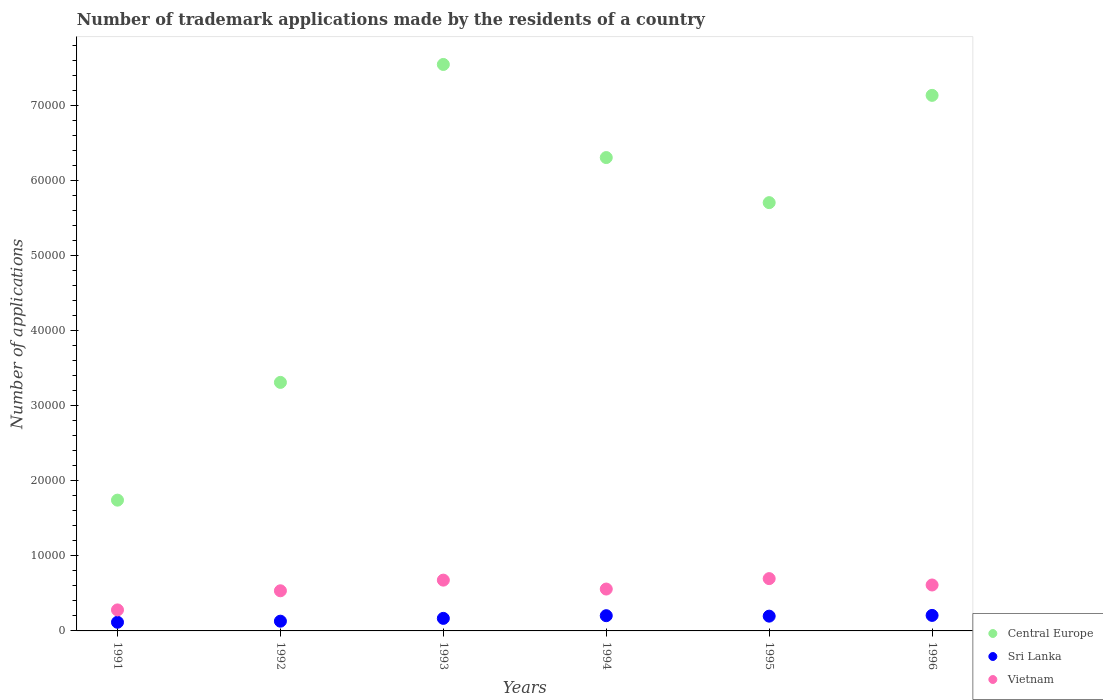Is the number of dotlines equal to the number of legend labels?
Keep it short and to the point. Yes. What is the number of trademark applications made by the residents in Vietnam in 1992?
Your answer should be very brief. 5345. Across all years, what is the maximum number of trademark applications made by the residents in Central Europe?
Your response must be concise. 7.54e+04. Across all years, what is the minimum number of trademark applications made by the residents in Central Europe?
Give a very brief answer. 1.74e+04. In which year was the number of trademark applications made by the residents in Central Europe maximum?
Provide a succinct answer. 1993. In which year was the number of trademark applications made by the residents in Central Europe minimum?
Offer a very short reply. 1991. What is the total number of trademark applications made by the residents in Central Europe in the graph?
Ensure brevity in your answer.  3.17e+05. What is the difference between the number of trademark applications made by the residents in Central Europe in 1991 and that in 1992?
Give a very brief answer. -1.57e+04. What is the difference between the number of trademark applications made by the residents in Sri Lanka in 1994 and the number of trademark applications made by the residents in Vietnam in 1996?
Your response must be concise. -4089. What is the average number of trademark applications made by the residents in Sri Lanka per year?
Your response must be concise. 1697. In the year 1992, what is the difference between the number of trademark applications made by the residents in Central Europe and number of trademark applications made by the residents in Vietnam?
Make the answer very short. 2.78e+04. What is the ratio of the number of trademark applications made by the residents in Central Europe in 1991 to that in 1996?
Make the answer very short. 0.24. Is the number of trademark applications made by the residents in Sri Lanka in 1992 less than that in 1995?
Make the answer very short. Yes. What is the difference between the highest and the second highest number of trademark applications made by the residents in Vietnam?
Ensure brevity in your answer.  202. What is the difference between the highest and the lowest number of trademark applications made by the residents in Vietnam?
Keep it short and to the point. 4168. In how many years, is the number of trademark applications made by the residents in Central Europe greater than the average number of trademark applications made by the residents in Central Europe taken over all years?
Your answer should be compact. 4. Is it the case that in every year, the sum of the number of trademark applications made by the residents in Vietnam and number of trademark applications made by the residents in Sri Lanka  is greater than the number of trademark applications made by the residents in Central Europe?
Keep it short and to the point. No. Does the number of trademark applications made by the residents in Sri Lanka monotonically increase over the years?
Keep it short and to the point. No. Is the number of trademark applications made by the residents in Central Europe strictly less than the number of trademark applications made by the residents in Sri Lanka over the years?
Give a very brief answer. No. How many dotlines are there?
Provide a succinct answer. 3. How many years are there in the graph?
Provide a succinct answer. 6. What is the difference between two consecutive major ticks on the Y-axis?
Provide a succinct answer. 10000. Does the graph contain any zero values?
Your answer should be compact. No. What is the title of the graph?
Provide a short and direct response. Number of trademark applications made by the residents of a country. What is the label or title of the Y-axis?
Provide a short and direct response. Number of applications. What is the Number of applications of Central Europe in 1991?
Your answer should be compact. 1.74e+04. What is the Number of applications in Sri Lanka in 1991?
Your answer should be very brief. 1153. What is the Number of applications of Vietnam in 1991?
Ensure brevity in your answer.  2798. What is the Number of applications in Central Europe in 1992?
Ensure brevity in your answer.  3.31e+04. What is the Number of applications in Sri Lanka in 1992?
Give a very brief answer. 1297. What is the Number of applications in Vietnam in 1992?
Your response must be concise. 5345. What is the Number of applications of Central Europe in 1993?
Provide a short and direct response. 7.54e+04. What is the Number of applications of Sri Lanka in 1993?
Your answer should be compact. 1671. What is the Number of applications of Vietnam in 1993?
Provide a succinct answer. 6764. What is the Number of applications of Central Europe in 1994?
Make the answer very short. 6.30e+04. What is the Number of applications in Sri Lanka in 1994?
Your answer should be very brief. 2028. What is the Number of applications of Vietnam in 1994?
Offer a very short reply. 5577. What is the Number of applications of Central Europe in 1995?
Ensure brevity in your answer.  5.70e+04. What is the Number of applications in Sri Lanka in 1995?
Your response must be concise. 1967. What is the Number of applications of Vietnam in 1995?
Your answer should be very brief. 6966. What is the Number of applications in Central Europe in 1996?
Ensure brevity in your answer.  7.13e+04. What is the Number of applications of Sri Lanka in 1996?
Provide a short and direct response. 2066. What is the Number of applications in Vietnam in 1996?
Provide a succinct answer. 6117. Across all years, what is the maximum Number of applications in Central Europe?
Offer a terse response. 7.54e+04. Across all years, what is the maximum Number of applications of Sri Lanka?
Ensure brevity in your answer.  2066. Across all years, what is the maximum Number of applications of Vietnam?
Give a very brief answer. 6966. Across all years, what is the minimum Number of applications in Central Europe?
Your answer should be very brief. 1.74e+04. Across all years, what is the minimum Number of applications of Sri Lanka?
Keep it short and to the point. 1153. Across all years, what is the minimum Number of applications of Vietnam?
Give a very brief answer. 2798. What is the total Number of applications in Central Europe in the graph?
Your answer should be very brief. 3.17e+05. What is the total Number of applications of Sri Lanka in the graph?
Your answer should be compact. 1.02e+04. What is the total Number of applications of Vietnam in the graph?
Offer a very short reply. 3.36e+04. What is the difference between the Number of applications in Central Europe in 1991 and that in 1992?
Your response must be concise. -1.57e+04. What is the difference between the Number of applications of Sri Lanka in 1991 and that in 1992?
Give a very brief answer. -144. What is the difference between the Number of applications in Vietnam in 1991 and that in 1992?
Provide a short and direct response. -2547. What is the difference between the Number of applications in Central Europe in 1991 and that in 1993?
Give a very brief answer. -5.80e+04. What is the difference between the Number of applications in Sri Lanka in 1991 and that in 1993?
Your answer should be very brief. -518. What is the difference between the Number of applications of Vietnam in 1991 and that in 1993?
Provide a succinct answer. -3966. What is the difference between the Number of applications of Central Europe in 1991 and that in 1994?
Provide a succinct answer. -4.56e+04. What is the difference between the Number of applications in Sri Lanka in 1991 and that in 1994?
Make the answer very short. -875. What is the difference between the Number of applications of Vietnam in 1991 and that in 1994?
Provide a short and direct response. -2779. What is the difference between the Number of applications of Central Europe in 1991 and that in 1995?
Offer a very short reply. -3.96e+04. What is the difference between the Number of applications of Sri Lanka in 1991 and that in 1995?
Provide a succinct answer. -814. What is the difference between the Number of applications of Vietnam in 1991 and that in 1995?
Ensure brevity in your answer.  -4168. What is the difference between the Number of applications in Central Europe in 1991 and that in 1996?
Provide a succinct answer. -5.39e+04. What is the difference between the Number of applications in Sri Lanka in 1991 and that in 1996?
Your answer should be very brief. -913. What is the difference between the Number of applications in Vietnam in 1991 and that in 1996?
Provide a short and direct response. -3319. What is the difference between the Number of applications of Central Europe in 1992 and that in 1993?
Offer a very short reply. -4.23e+04. What is the difference between the Number of applications of Sri Lanka in 1992 and that in 1993?
Your answer should be very brief. -374. What is the difference between the Number of applications of Vietnam in 1992 and that in 1993?
Ensure brevity in your answer.  -1419. What is the difference between the Number of applications in Central Europe in 1992 and that in 1994?
Provide a short and direct response. -2.99e+04. What is the difference between the Number of applications of Sri Lanka in 1992 and that in 1994?
Your answer should be compact. -731. What is the difference between the Number of applications of Vietnam in 1992 and that in 1994?
Ensure brevity in your answer.  -232. What is the difference between the Number of applications of Central Europe in 1992 and that in 1995?
Offer a terse response. -2.39e+04. What is the difference between the Number of applications in Sri Lanka in 1992 and that in 1995?
Offer a very short reply. -670. What is the difference between the Number of applications of Vietnam in 1992 and that in 1995?
Ensure brevity in your answer.  -1621. What is the difference between the Number of applications of Central Europe in 1992 and that in 1996?
Make the answer very short. -3.82e+04. What is the difference between the Number of applications in Sri Lanka in 1992 and that in 1996?
Ensure brevity in your answer.  -769. What is the difference between the Number of applications of Vietnam in 1992 and that in 1996?
Offer a terse response. -772. What is the difference between the Number of applications in Central Europe in 1993 and that in 1994?
Provide a short and direct response. 1.24e+04. What is the difference between the Number of applications of Sri Lanka in 1993 and that in 1994?
Give a very brief answer. -357. What is the difference between the Number of applications of Vietnam in 1993 and that in 1994?
Your response must be concise. 1187. What is the difference between the Number of applications in Central Europe in 1993 and that in 1995?
Provide a succinct answer. 1.84e+04. What is the difference between the Number of applications in Sri Lanka in 1993 and that in 1995?
Offer a terse response. -296. What is the difference between the Number of applications of Vietnam in 1993 and that in 1995?
Give a very brief answer. -202. What is the difference between the Number of applications of Central Europe in 1993 and that in 1996?
Offer a terse response. 4115. What is the difference between the Number of applications in Sri Lanka in 1993 and that in 1996?
Ensure brevity in your answer.  -395. What is the difference between the Number of applications in Vietnam in 1993 and that in 1996?
Your answer should be compact. 647. What is the difference between the Number of applications of Central Europe in 1994 and that in 1995?
Your response must be concise. 6003. What is the difference between the Number of applications in Sri Lanka in 1994 and that in 1995?
Provide a short and direct response. 61. What is the difference between the Number of applications of Vietnam in 1994 and that in 1995?
Your response must be concise. -1389. What is the difference between the Number of applications in Central Europe in 1994 and that in 1996?
Make the answer very short. -8284. What is the difference between the Number of applications of Sri Lanka in 1994 and that in 1996?
Provide a short and direct response. -38. What is the difference between the Number of applications in Vietnam in 1994 and that in 1996?
Your answer should be very brief. -540. What is the difference between the Number of applications of Central Europe in 1995 and that in 1996?
Make the answer very short. -1.43e+04. What is the difference between the Number of applications in Sri Lanka in 1995 and that in 1996?
Your answer should be very brief. -99. What is the difference between the Number of applications of Vietnam in 1995 and that in 1996?
Give a very brief answer. 849. What is the difference between the Number of applications of Central Europe in 1991 and the Number of applications of Sri Lanka in 1992?
Provide a short and direct response. 1.61e+04. What is the difference between the Number of applications in Central Europe in 1991 and the Number of applications in Vietnam in 1992?
Offer a terse response. 1.21e+04. What is the difference between the Number of applications in Sri Lanka in 1991 and the Number of applications in Vietnam in 1992?
Offer a terse response. -4192. What is the difference between the Number of applications of Central Europe in 1991 and the Number of applications of Sri Lanka in 1993?
Provide a short and direct response. 1.57e+04. What is the difference between the Number of applications in Central Europe in 1991 and the Number of applications in Vietnam in 1993?
Offer a terse response. 1.07e+04. What is the difference between the Number of applications in Sri Lanka in 1991 and the Number of applications in Vietnam in 1993?
Offer a very short reply. -5611. What is the difference between the Number of applications of Central Europe in 1991 and the Number of applications of Sri Lanka in 1994?
Make the answer very short. 1.54e+04. What is the difference between the Number of applications in Central Europe in 1991 and the Number of applications in Vietnam in 1994?
Your response must be concise. 1.18e+04. What is the difference between the Number of applications of Sri Lanka in 1991 and the Number of applications of Vietnam in 1994?
Keep it short and to the point. -4424. What is the difference between the Number of applications of Central Europe in 1991 and the Number of applications of Sri Lanka in 1995?
Your response must be concise. 1.54e+04. What is the difference between the Number of applications of Central Europe in 1991 and the Number of applications of Vietnam in 1995?
Provide a succinct answer. 1.05e+04. What is the difference between the Number of applications of Sri Lanka in 1991 and the Number of applications of Vietnam in 1995?
Give a very brief answer. -5813. What is the difference between the Number of applications of Central Europe in 1991 and the Number of applications of Sri Lanka in 1996?
Your answer should be very brief. 1.54e+04. What is the difference between the Number of applications of Central Europe in 1991 and the Number of applications of Vietnam in 1996?
Provide a succinct answer. 1.13e+04. What is the difference between the Number of applications of Sri Lanka in 1991 and the Number of applications of Vietnam in 1996?
Provide a succinct answer. -4964. What is the difference between the Number of applications of Central Europe in 1992 and the Number of applications of Sri Lanka in 1993?
Your answer should be compact. 3.14e+04. What is the difference between the Number of applications in Central Europe in 1992 and the Number of applications in Vietnam in 1993?
Give a very brief answer. 2.63e+04. What is the difference between the Number of applications in Sri Lanka in 1992 and the Number of applications in Vietnam in 1993?
Provide a succinct answer. -5467. What is the difference between the Number of applications of Central Europe in 1992 and the Number of applications of Sri Lanka in 1994?
Give a very brief answer. 3.11e+04. What is the difference between the Number of applications of Central Europe in 1992 and the Number of applications of Vietnam in 1994?
Your answer should be compact. 2.75e+04. What is the difference between the Number of applications in Sri Lanka in 1992 and the Number of applications in Vietnam in 1994?
Provide a succinct answer. -4280. What is the difference between the Number of applications of Central Europe in 1992 and the Number of applications of Sri Lanka in 1995?
Make the answer very short. 3.11e+04. What is the difference between the Number of applications in Central Europe in 1992 and the Number of applications in Vietnam in 1995?
Give a very brief answer. 2.61e+04. What is the difference between the Number of applications of Sri Lanka in 1992 and the Number of applications of Vietnam in 1995?
Your answer should be very brief. -5669. What is the difference between the Number of applications in Central Europe in 1992 and the Number of applications in Sri Lanka in 1996?
Offer a very short reply. 3.10e+04. What is the difference between the Number of applications of Central Europe in 1992 and the Number of applications of Vietnam in 1996?
Make the answer very short. 2.70e+04. What is the difference between the Number of applications of Sri Lanka in 1992 and the Number of applications of Vietnam in 1996?
Offer a terse response. -4820. What is the difference between the Number of applications of Central Europe in 1993 and the Number of applications of Sri Lanka in 1994?
Provide a succinct answer. 7.34e+04. What is the difference between the Number of applications of Central Europe in 1993 and the Number of applications of Vietnam in 1994?
Ensure brevity in your answer.  6.99e+04. What is the difference between the Number of applications of Sri Lanka in 1993 and the Number of applications of Vietnam in 1994?
Ensure brevity in your answer.  -3906. What is the difference between the Number of applications of Central Europe in 1993 and the Number of applications of Sri Lanka in 1995?
Give a very brief answer. 7.35e+04. What is the difference between the Number of applications of Central Europe in 1993 and the Number of applications of Vietnam in 1995?
Your response must be concise. 6.85e+04. What is the difference between the Number of applications in Sri Lanka in 1993 and the Number of applications in Vietnam in 1995?
Your answer should be compact. -5295. What is the difference between the Number of applications of Central Europe in 1993 and the Number of applications of Sri Lanka in 1996?
Provide a short and direct response. 7.34e+04. What is the difference between the Number of applications in Central Europe in 1993 and the Number of applications in Vietnam in 1996?
Ensure brevity in your answer.  6.93e+04. What is the difference between the Number of applications of Sri Lanka in 1993 and the Number of applications of Vietnam in 1996?
Your answer should be very brief. -4446. What is the difference between the Number of applications in Central Europe in 1994 and the Number of applications in Sri Lanka in 1995?
Make the answer very short. 6.11e+04. What is the difference between the Number of applications of Central Europe in 1994 and the Number of applications of Vietnam in 1995?
Your response must be concise. 5.61e+04. What is the difference between the Number of applications of Sri Lanka in 1994 and the Number of applications of Vietnam in 1995?
Your answer should be compact. -4938. What is the difference between the Number of applications in Central Europe in 1994 and the Number of applications in Sri Lanka in 1996?
Your answer should be compact. 6.10e+04. What is the difference between the Number of applications of Central Europe in 1994 and the Number of applications of Vietnam in 1996?
Offer a very short reply. 5.69e+04. What is the difference between the Number of applications in Sri Lanka in 1994 and the Number of applications in Vietnam in 1996?
Ensure brevity in your answer.  -4089. What is the difference between the Number of applications of Central Europe in 1995 and the Number of applications of Sri Lanka in 1996?
Provide a short and direct response. 5.50e+04. What is the difference between the Number of applications of Central Europe in 1995 and the Number of applications of Vietnam in 1996?
Keep it short and to the point. 5.09e+04. What is the difference between the Number of applications of Sri Lanka in 1995 and the Number of applications of Vietnam in 1996?
Your response must be concise. -4150. What is the average Number of applications of Central Europe per year?
Give a very brief answer. 5.29e+04. What is the average Number of applications of Sri Lanka per year?
Your response must be concise. 1697. What is the average Number of applications of Vietnam per year?
Provide a short and direct response. 5594.5. In the year 1991, what is the difference between the Number of applications of Central Europe and Number of applications of Sri Lanka?
Offer a terse response. 1.63e+04. In the year 1991, what is the difference between the Number of applications in Central Europe and Number of applications in Vietnam?
Offer a very short reply. 1.46e+04. In the year 1991, what is the difference between the Number of applications of Sri Lanka and Number of applications of Vietnam?
Provide a short and direct response. -1645. In the year 1992, what is the difference between the Number of applications in Central Europe and Number of applications in Sri Lanka?
Give a very brief answer. 3.18e+04. In the year 1992, what is the difference between the Number of applications of Central Europe and Number of applications of Vietnam?
Ensure brevity in your answer.  2.78e+04. In the year 1992, what is the difference between the Number of applications in Sri Lanka and Number of applications in Vietnam?
Your response must be concise. -4048. In the year 1993, what is the difference between the Number of applications in Central Europe and Number of applications in Sri Lanka?
Your answer should be very brief. 7.38e+04. In the year 1993, what is the difference between the Number of applications of Central Europe and Number of applications of Vietnam?
Provide a succinct answer. 6.87e+04. In the year 1993, what is the difference between the Number of applications in Sri Lanka and Number of applications in Vietnam?
Make the answer very short. -5093. In the year 1994, what is the difference between the Number of applications in Central Europe and Number of applications in Sri Lanka?
Your answer should be compact. 6.10e+04. In the year 1994, what is the difference between the Number of applications in Central Europe and Number of applications in Vietnam?
Keep it short and to the point. 5.75e+04. In the year 1994, what is the difference between the Number of applications in Sri Lanka and Number of applications in Vietnam?
Give a very brief answer. -3549. In the year 1995, what is the difference between the Number of applications in Central Europe and Number of applications in Sri Lanka?
Keep it short and to the point. 5.51e+04. In the year 1995, what is the difference between the Number of applications in Central Europe and Number of applications in Vietnam?
Provide a short and direct response. 5.01e+04. In the year 1995, what is the difference between the Number of applications in Sri Lanka and Number of applications in Vietnam?
Give a very brief answer. -4999. In the year 1996, what is the difference between the Number of applications in Central Europe and Number of applications in Sri Lanka?
Offer a terse response. 6.93e+04. In the year 1996, what is the difference between the Number of applications of Central Europe and Number of applications of Vietnam?
Give a very brief answer. 6.52e+04. In the year 1996, what is the difference between the Number of applications of Sri Lanka and Number of applications of Vietnam?
Provide a succinct answer. -4051. What is the ratio of the Number of applications of Central Europe in 1991 to that in 1992?
Provide a short and direct response. 0.53. What is the ratio of the Number of applications of Sri Lanka in 1991 to that in 1992?
Your answer should be very brief. 0.89. What is the ratio of the Number of applications in Vietnam in 1991 to that in 1992?
Provide a short and direct response. 0.52. What is the ratio of the Number of applications of Central Europe in 1991 to that in 1993?
Give a very brief answer. 0.23. What is the ratio of the Number of applications of Sri Lanka in 1991 to that in 1993?
Your response must be concise. 0.69. What is the ratio of the Number of applications in Vietnam in 1991 to that in 1993?
Your answer should be very brief. 0.41. What is the ratio of the Number of applications of Central Europe in 1991 to that in 1994?
Your answer should be compact. 0.28. What is the ratio of the Number of applications of Sri Lanka in 1991 to that in 1994?
Offer a terse response. 0.57. What is the ratio of the Number of applications in Vietnam in 1991 to that in 1994?
Offer a very short reply. 0.5. What is the ratio of the Number of applications of Central Europe in 1991 to that in 1995?
Your response must be concise. 0.31. What is the ratio of the Number of applications in Sri Lanka in 1991 to that in 1995?
Give a very brief answer. 0.59. What is the ratio of the Number of applications in Vietnam in 1991 to that in 1995?
Ensure brevity in your answer.  0.4. What is the ratio of the Number of applications of Central Europe in 1991 to that in 1996?
Keep it short and to the point. 0.24. What is the ratio of the Number of applications of Sri Lanka in 1991 to that in 1996?
Make the answer very short. 0.56. What is the ratio of the Number of applications in Vietnam in 1991 to that in 1996?
Ensure brevity in your answer.  0.46. What is the ratio of the Number of applications in Central Europe in 1992 to that in 1993?
Provide a short and direct response. 0.44. What is the ratio of the Number of applications in Sri Lanka in 1992 to that in 1993?
Make the answer very short. 0.78. What is the ratio of the Number of applications in Vietnam in 1992 to that in 1993?
Make the answer very short. 0.79. What is the ratio of the Number of applications of Central Europe in 1992 to that in 1994?
Your answer should be very brief. 0.53. What is the ratio of the Number of applications of Sri Lanka in 1992 to that in 1994?
Give a very brief answer. 0.64. What is the ratio of the Number of applications in Vietnam in 1992 to that in 1994?
Give a very brief answer. 0.96. What is the ratio of the Number of applications of Central Europe in 1992 to that in 1995?
Provide a succinct answer. 0.58. What is the ratio of the Number of applications of Sri Lanka in 1992 to that in 1995?
Your answer should be compact. 0.66. What is the ratio of the Number of applications of Vietnam in 1992 to that in 1995?
Provide a short and direct response. 0.77. What is the ratio of the Number of applications of Central Europe in 1992 to that in 1996?
Provide a succinct answer. 0.46. What is the ratio of the Number of applications of Sri Lanka in 1992 to that in 1996?
Make the answer very short. 0.63. What is the ratio of the Number of applications in Vietnam in 1992 to that in 1996?
Offer a very short reply. 0.87. What is the ratio of the Number of applications in Central Europe in 1993 to that in 1994?
Provide a short and direct response. 1.2. What is the ratio of the Number of applications in Sri Lanka in 1993 to that in 1994?
Offer a terse response. 0.82. What is the ratio of the Number of applications of Vietnam in 1993 to that in 1994?
Keep it short and to the point. 1.21. What is the ratio of the Number of applications of Central Europe in 1993 to that in 1995?
Provide a succinct answer. 1.32. What is the ratio of the Number of applications in Sri Lanka in 1993 to that in 1995?
Provide a succinct answer. 0.85. What is the ratio of the Number of applications in Central Europe in 1993 to that in 1996?
Ensure brevity in your answer.  1.06. What is the ratio of the Number of applications of Sri Lanka in 1993 to that in 1996?
Make the answer very short. 0.81. What is the ratio of the Number of applications of Vietnam in 1993 to that in 1996?
Ensure brevity in your answer.  1.11. What is the ratio of the Number of applications in Central Europe in 1994 to that in 1995?
Keep it short and to the point. 1.11. What is the ratio of the Number of applications of Sri Lanka in 1994 to that in 1995?
Your answer should be very brief. 1.03. What is the ratio of the Number of applications of Vietnam in 1994 to that in 1995?
Keep it short and to the point. 0.8. What is the ratio of the Number of applications of Central Europe in 1994 to that in 1996?
Keep it short and to the point. 0.88. What is the ratio of the Number of applications in Sri Lanka in 1994 to that in 1996?
Keep it short and to the point. 0.98. What is the ratio of the Number of applications of Vietnam in 1994 to that in 1996?
Your response must be concise. 0.91. What is the ratio of the Number of applications of Central Europe in 1995 to that in 1996?
Give a very brief answer. 0.8. What is the ratio of the Number of applications of Sri Lanka in 1995 to that in 1996?
Keep it short and to the point. 0.95. What is the ratio of the Number of applications of Vietnam in 1995 to that in 1996?
Your response must be concise. 1.14. What is the difference between the highest and the second highest Number of applications of Central Europe?
Your response must be concise. 4115. What is the difference between the highest and the second highest Number of applications of Vietnam?
Offer a terse response. 202. What is the difference between the highest and the lowest Number of applications of Central Europe?
Give a very brief answer. 5.80e+04. What is the difference between the highest and the lowest Number of applications of Sri Lanka?
Your answer should be very brief. 913. What is the difference between the highest and the lowest Number of applications in Vietnam?
Provide a short and direct response. 4168. 